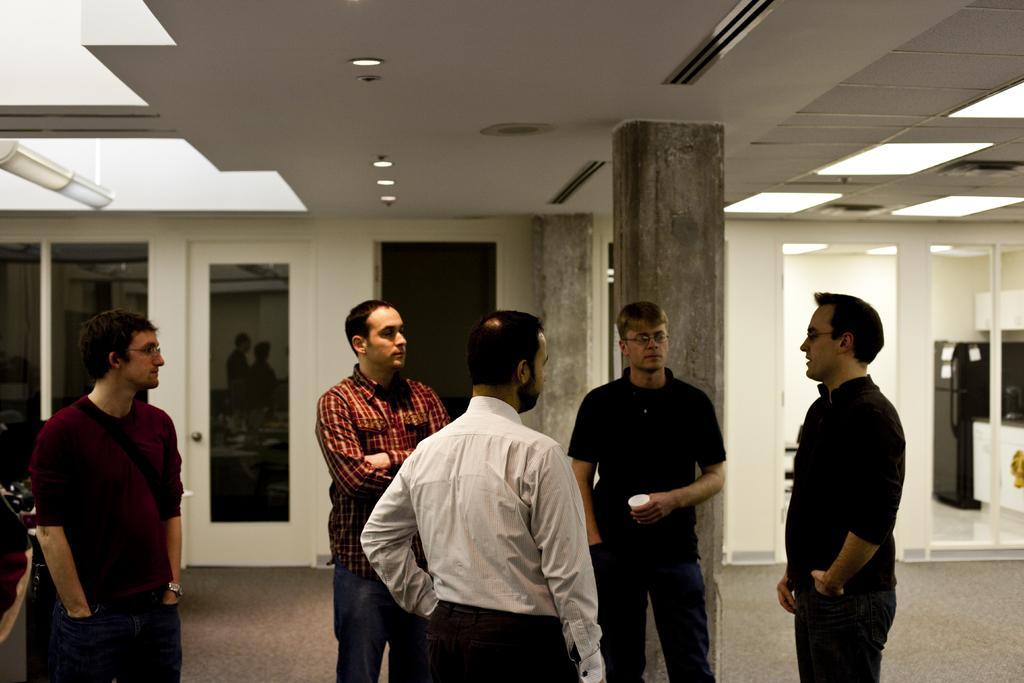Can you describe this image briefly? In this picture, we see five men are standing. Behind them, we see the pillars. In the background, we see a white wall and doors. On the right side, we see a refrigerator in black color. At the top, we see the ceiling of the room. 